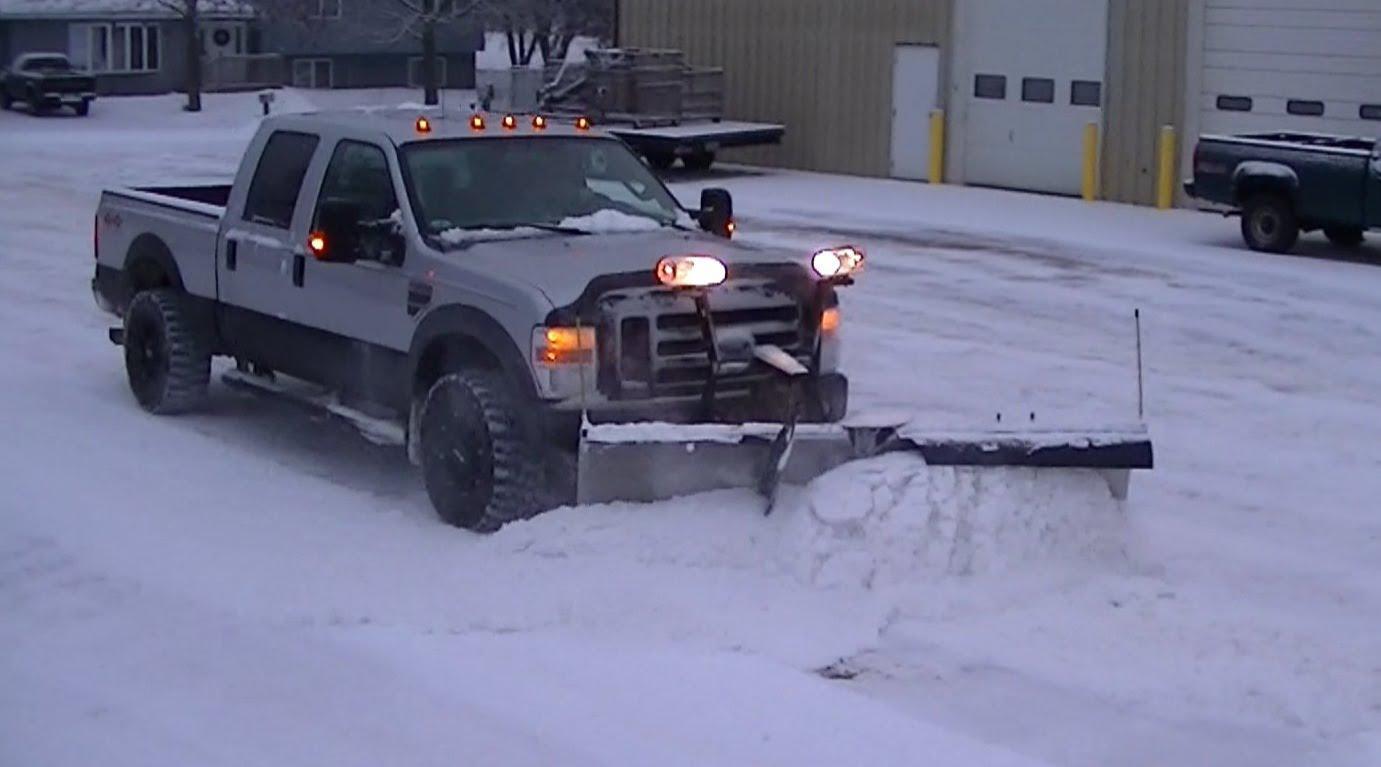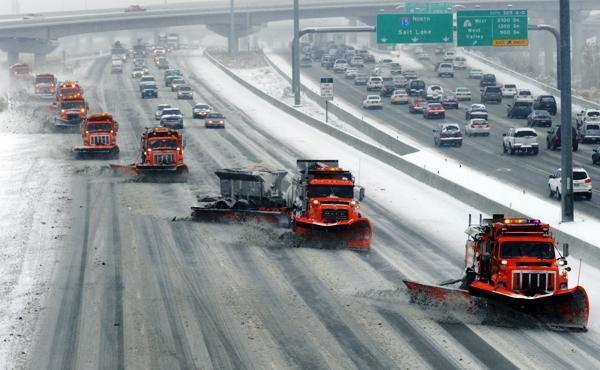The first image is the image on the left, the second image is the image on the right. Considering the images on both sides, is "At least one of the images shows a highway scene." valid? Answer yes or no. Yes. 